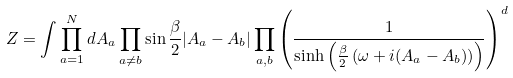<formula> <loc_0><loc_0><loc_500><loc_500>Z = \int \prod _ { a = 1 } ^ { N } d A _ { a } \prod _ { a \neq b } \sin \frac { \beta } { 2 } | A _ { a } - A _ { b } | \prod _ { a , b } \left ( \frac { 1 } { \sinh \left ( \frac { \beta } { 2 } \left ( \omega + i ( A _ { a } - A _ { b } ) \right ) \right ) } \right ) ^ { d }</formula> 